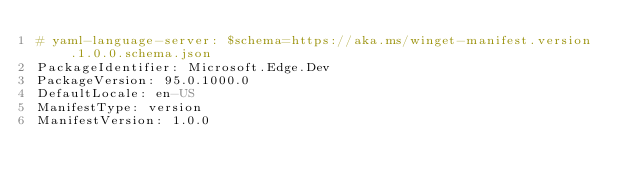Convert code to text. <code><loc_0><loc_0><loc_500><loc_500><_YAML_># yaml-language-server: $schema=https://aka.ms/winget-manifest.version.1.0.0.schema.json
PackageIdentifier: Microsoft.Edge.Dev
PackageVersion: 95.0.1000.0
DefaultLocale: en-US
ManifestType: version
ManifestVersion: 1.0.0


</code> 